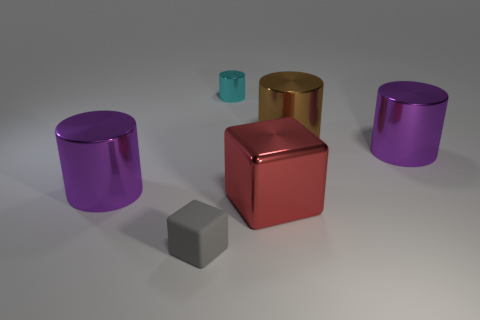Add 3 big metallic blocks. How many objects exist? 9 Subtract all blocks. How many objects are left? 4 Add 2 large red shiny things. How many large red shiny things are left? 3 Add 4 tiny green objects. How many tiny green objects exist? 4 Subtract 0 purple spheres. How many objects are left? 6 Subtract all brown cylinders. Subtract all cyan shiny objects. How many objects are left? 4 